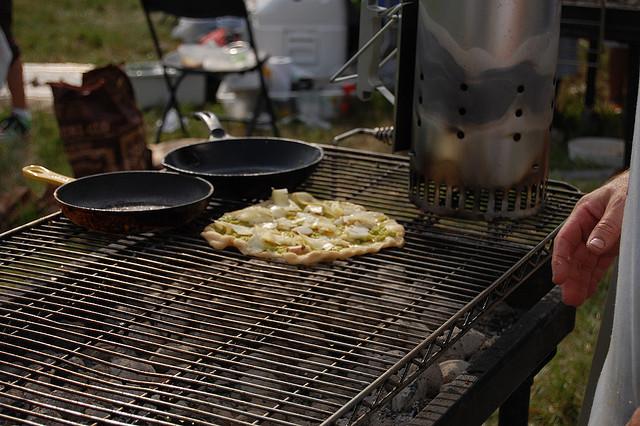What toppings are on the pizza?
Short answer required. Onions. How many pans are shown?
Quick response, please. 2. Where was this cooked?
Be succinct. Grill. What type of food is on the grill?
Keep it brief. Pizza. Is there a cozy on the teapot?
Keep it brief. No. Is there a cheese grater in this picture?
Keep it brief. No. What are the pots on top of?
Answer briefly. Grill. What is this place called?
Short answer required. Backyard. What material is the table?
Keep it brief. Metal. Is this in a bakery?
Keep it brief. No. Where is the food?
Answer briefly. Grill. How many knives are in the picture?
Concise answer only. 0. Is this homemade pizza?
Concise answer only. Yes. What is she cooking?
Keep it brief. Pizza. What gender is not represented?
Answer briefly. Female. Is the pizza big?
Concise answer only. No. How many hamburgers are being cooked?
Give a very brief answer. 0. Is the person grilling?
Quick response, please. Yes. What are the cooks preparing?
Keep it brief. Pizza. What is in the picture?
Write a very short answer. Grill. Are they in a restaurant?
Be succinct. No. 